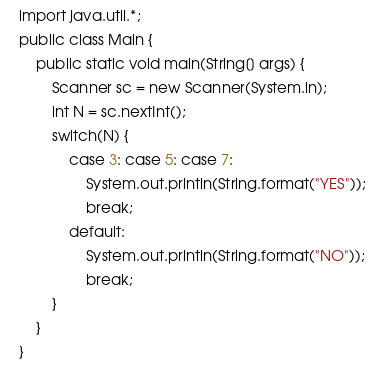Convert code to text. <code><loc_0><loc_0><loc_500><loc_500><_Java_>import java.util.*;
public class Main {
    public static void main(String[] args) {
        Scanner sc = new Scanner(System.in);
        int N = sc.nextInt();
        switch(N) {
            case 3: case 5: case 7:
                System.out.println(String.format("YES"));
                break;
            default:
                System.out.println(String.format("NO"));
                break;
        }
    }
}
</code> 